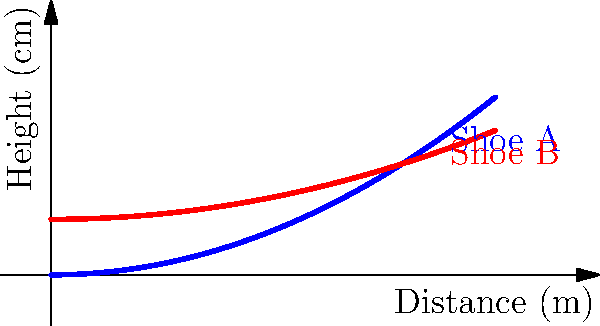The graph shows the side profile of two running shoes. Shoe A has a more curved design, while Shoe B has a flatter profile with a slight lift. Which shoe design is likely to have better aerodynamics for a marathon runner, and why? To determine which shoe has better aerodynamics, we need to consider how air flows over the shoe during running:

1. Air resistance: The primary factor affecting aerodynamics is the amount of air resistance (drag) created by the shoe's shape.

2. Shoe A (curved profile):
   - Creates a more streamlined shape
   - Allows air to flow smoothly over the shoe
   - Reduces turbulence and drag

3. Shoe B (flatter profile with slight lift):
   - Has a more abrupt change in shape
   - Creates more turbulence as air flows over it
   - Likely to produce more drag

4. Impact on running:
   - Lower drag means less energy expended by the runner
   - Over long distances (like a marathon), this energy saving can be significant

5. Additional considerations:
   - The curved design of Shoe A may also provide better energy return during the running gait
   - However, individual running style and foot shape also play a role in shoe performance

Given these factors, Shoe A with its curved profile is likely to have better aerodynamics for a marathon runner, as it would create less air resistance and potentially improve energy efficiency over long distances.
Answer: Shoe A (curved profile) has better aerodynamics due to reduced air resistance. 